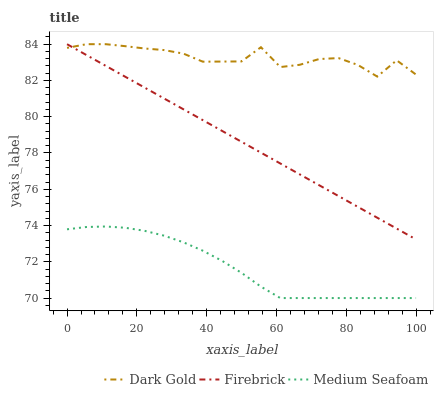Does Medium Seafoam have the minimum area under the curve?
Answer yes or no. Yes. Does Dark Gold have the maximum area under the curve?
Answer yes or no. Yes. Does Dark Gold have the minimum area under the curve?
Answer yes or no. No. Does Medium Seafoam have the maximum area under the curve?
Answer yes or no. No. Is Firebrick the smoothest?
Answer yes or no. Yes. Is Dark Gold the roughest?
Answer yes or no. Yes. Is Medium Seafoam the smoothest?
Answer yes or no. No. Is Medium Seafoam the roughest?
Answer yes or no. No. Does Dark Gold have the lowest value?
Answer yes or no. No. Does Dark Gold have the highest value?
Answer yes or no. Yes. Does Medium Seafoam have the highest value?
Answer yes or no. No. Is Medium Seafoam less than Firebrick?
Answer yes or no. Yes. Is Firebrick greater than Medium Seafoam?
Answer yes or no. Yes. Does Medium Seafoam intersect Firebrick?
Answer yes or no. No. 